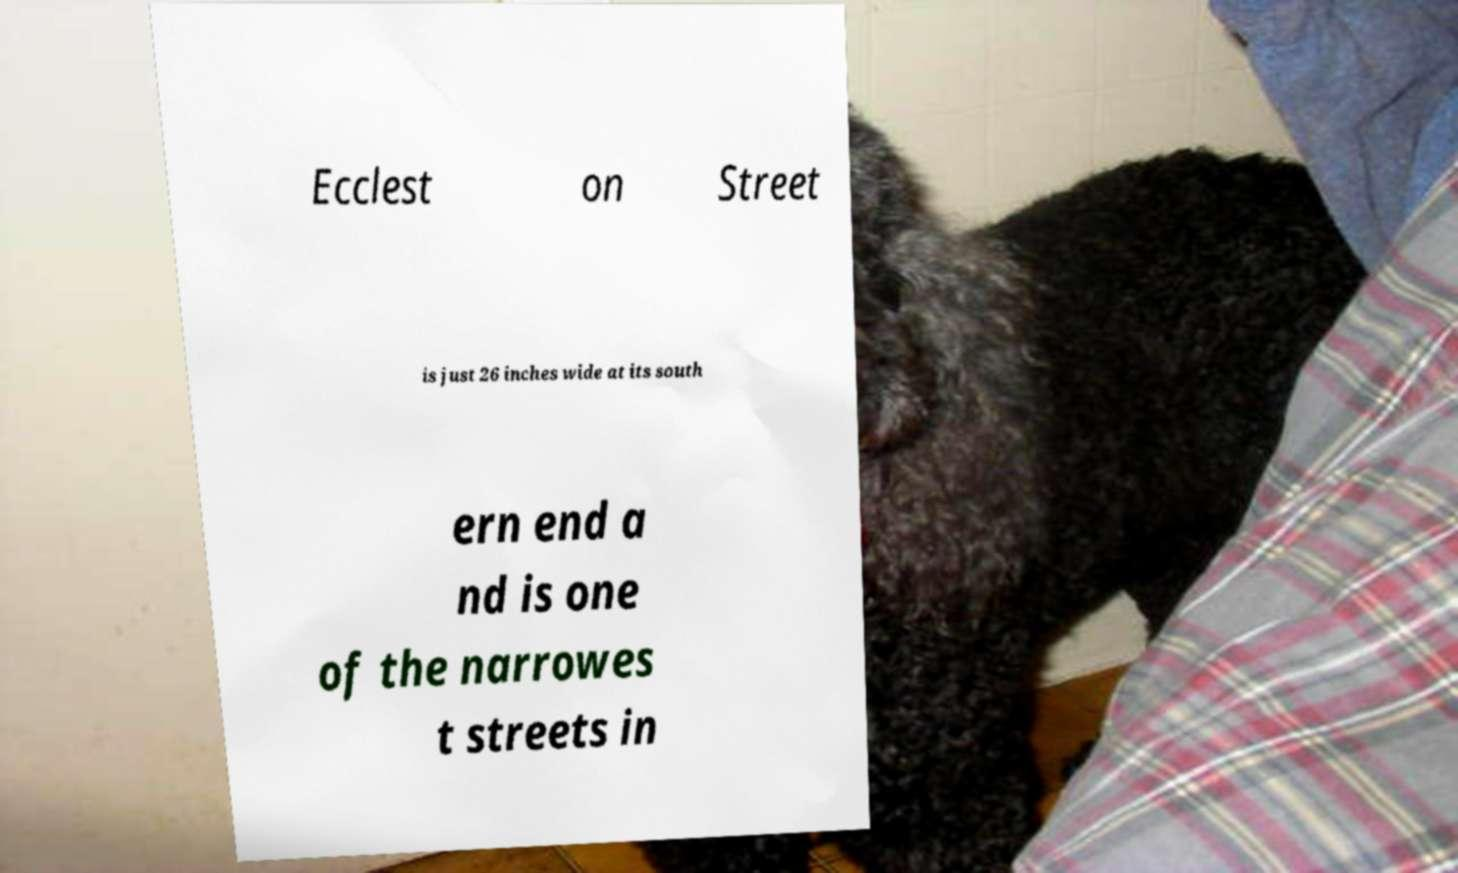What messages or text are displayed in this image? I need them in a readable, typed format. Ecclest on Street is just 26 inches wide at its south ern end a nd is one of the narrowes t streets in 